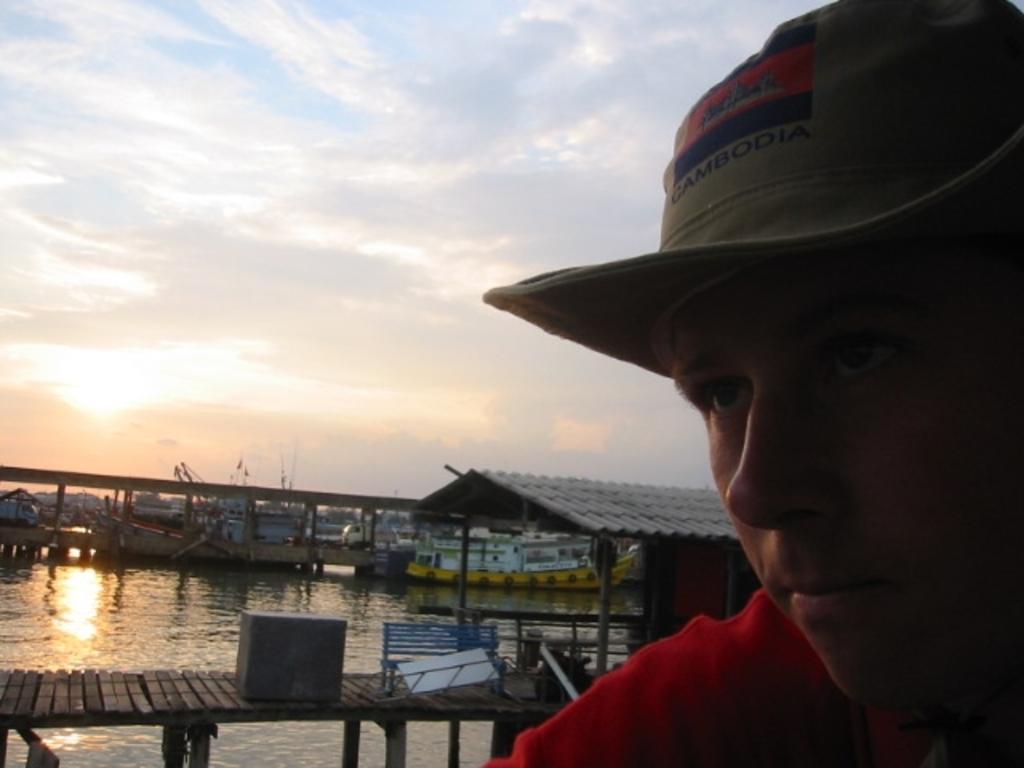Could you give a brief overview of what you see in this image? In this image we can see a man. In the background there are walkway bridge, shed, ships at the deck and sky with clouds. 